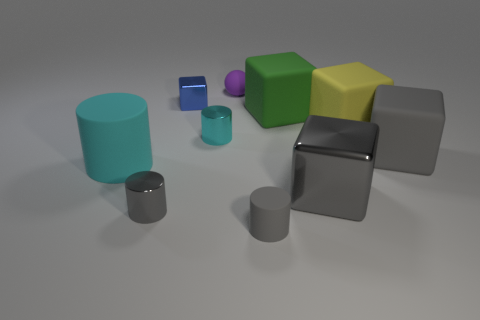How many small purple rubber things are to the left of the tiny rubber ball?
Give a very brief answer. 0. How many cyan things are either large cylinders or matte things?
Keep it short and to the point. 1. There is another gray cylinder that is the same size as the gray rubber cylinder; what is it made of?
Your response must be concise. Metal. There is a thing that is in front of the big yellow object and behind the large gray rubber block; what is its shape?
Provide a succinct answer. Cylinder. The other metal thing that is the same size as the yellow thing is what color?
Ensure brevity in your answer.  Gray. There is a matte cylinder that is to the right of the small blue metal object; is its size the same as the gray thing that is behind the large cyan cylinder?
Provide a succinct answer. No. There is a gray metallic cube in front of the rubber cylinder that is to the left of the tiny gray thing to the right of the purple object; how big is it?
Offer a very short reply. Large. There is a tiny metal object that is on the right side of the blue metallic thing that is behind the tiny cyan metallic cylinder; what shape is it?
Offer a very short reply. Cylinder. There is a matte cylinder on the right side of the ball; does it have the same color as the big metallic cube?
Provide a succinct answer. Yes. What color is the large thing that is right of the big gray metal thing and in front of the small cyan metallic thing?
Your response must be concise. Gray. 